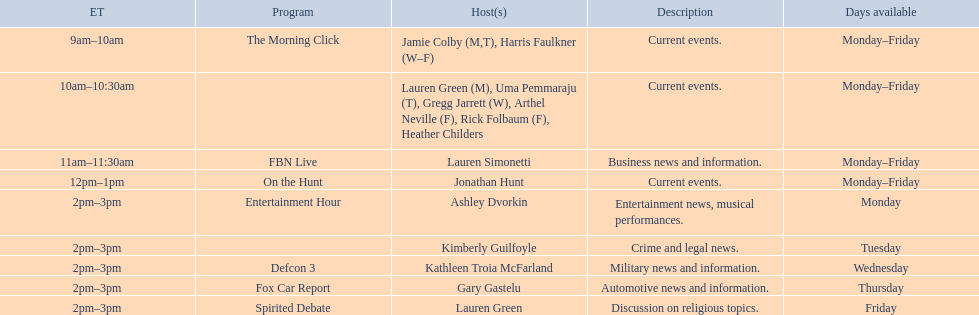Which programs broadcast by fox news channel hosts are listed? Jamie Colby (M,T), Harris Faulkner (W–F), Lauren Green (M), Uma Pemmaraju (T), Gregg Jarrett (W), Arthel Neville (F), Rick Folbaum (F), Heather Childers, Lauren Simonetti, Jonathan Hunt, Ashley Dvorkin, Kimberly Guilfoyle, Kathleen Troia McFarland, Gary Gastelu, Lauren Green. Of those, who have shows on friday? Jamie Colby (M,T), Harris Faulkner (W–F), Lauren Green (M), Uma Pemmaraju (T), Gregg Jarrett (W), Arthel Neville (F), Rick Folbaum (F), Heather Childers, Lauren Simonetti, Jonathan Hunt, Lauren Green. Of those, whose is at 2 pm? Lauren Green. 